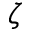Convert formula to latex. <formula><loc_0><loc_0><loc_500><loc_500>\zeta</formula> 